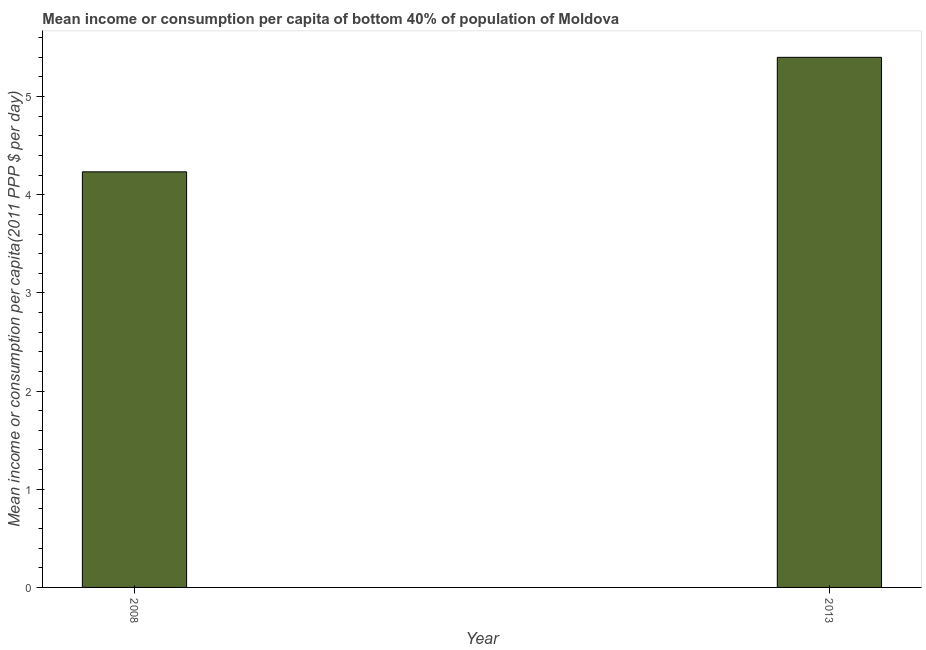What is the title of the graph?
Make the answer very short. Mean income or consumption per capita of bottom 40% of population of Moldova. What is the label or title of the Y-axis?
Offer a very short reply. Mean income or consumption per capita(2011 PPP $ per day). What is the mean income or consumption in 2013?
Your answer should be very brief. 5.4. Across all years, what is the maximum mean income or consumption?
Your answer should be compact. 5.4. Across all years, what is the minimum mean income or consumption?
Your response must be concise. 4.23. What is the sum of the mean income or consumption?
Your answer should be compact. 9.63. What is the difference between the mean income or consumption in 2008 and 2013?
Provide a succinct answer. -1.17. What is the average mean income or consumption per year?
Your response must be concise. 4.82. What is the median mean income or consumption?
Offer a very short reply. 4.82. In how many years, is the mean income or consumption greater than 3.2 $?
Make the answer very short. 2. Do a majority of the years between 2008 and 2013 (inclusive) have mean income or consumption greater than 2 $?
Your answer should be very brief. Yes. What is the ratio of the mean income or consumption in 2008 to that in 2013?
Offer a terse response. 0.78. Is the mean income or consumption in 2008 less than that in 2013?
Give a very brief answer. Yes. In how many years, is the mean income or consumption greater than the average mean income or consumption taken over all years?
Provide a short and direct response. 1. What is the difference between two consecutive major ticks on the Y-axis?
Keep it short and to the point. 1. Are the values on the major ticks of Y-axis written in scientific E-notation?
Offer a very short reply. No. What is the Mean income or consumption per capita(2011 PPP $ per day) in 2008?
Provide a succinct answer. 4.23. What is the Mean income or consumption per capita(2011 PPP $ per day) of 2013?
Give a very brief answer. 5.4. What is the difference between the Mean income or consumption per capita(2011 PPP $ per day) in 2008 and 2013?
Keep it short and to the point. -1.17. What is the ratio of the Mean income or consumption per capita(2011 PPP $ per day) in 2008 to that in 2013?
Keep it short and to the point. 0.78. 